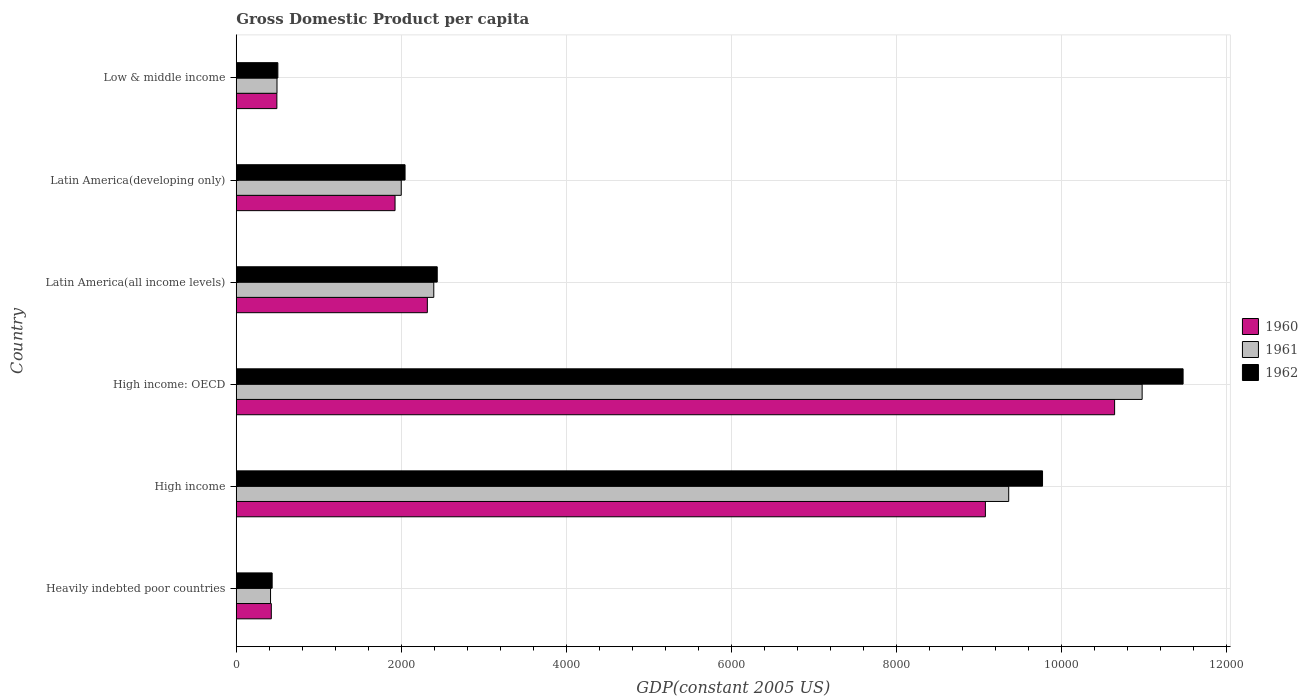How many different coloured bars are there?
Offer a terse response. 3. Are the number of bars per tick equal to the number of legend labels?
Ensure brevity in your answer.  Yes. What is the label of the 5th group of bars from the top?
Your answer should be very brief. High income. In how many cases, is the number of bars for a given country not equal to the number of legend labels?
Keep it short and to the point. 0. What is the GDP per capita in 1962 in High income?
Your response must be concise. 9773.42. Across all countries, what is the maximum GDP per capita in 1962?
Make the answer very short. 1.15e+04. Across all countries, what is the minimum GDP per capita in 1960?
Your response must be concise. 424.89. In which country was the GDP per capita in 1960 maximum?
Offer a terse response. High income: OECD. In which country was the GDP per capita in 1960 minimum?
Provide a short and direct response. Heavily indebted poor countries. What is the total GDP per capita in 1961 in the graph?
Offer a very short reply. 2.56e+04. What is the difference between the GDP per capita in 1962 in High income and that in Latin America(developing only)?
Make the answer very short. 7727.21. What is the difference between the GDP per capita in 1961 in Latin America(all income levels) and the GDP per capita in 1962 in Latin America(developing only)?
Offer a very short reply. 348.12. What is the average GDP per capita in 1962 per country?
Offer a terse response. 4445.4. What is the difference between the GDP per capita in 1960 and GDP per capita in 1962 in Low & middle income?
Your answer should be compact. -11.86. In how many countries, is the GDP per capita in 1962 greater than 3200 US$?
Your answer should be compact. 2. What is the ratio of the GDP per capita in 1962 in Heavily indebted poor countries to that in High income?
Your answer should be compact. 0.04. What is the difference between the highest and the second highest GDP per capita in 1960?
Ensure brevity in your answer.  1566.31. What is the difference between the highest and the lowest GDP per capita in 1961?
Your response must be concise. 1.06e+04. In how many countries, is the GDP per capita in 1960 greater than the average GDP per capita in 1960 taken over all countries?
Give a very brief answer. 2. Are all the bars in the graph horizontal?
Provide a succinct answer. Yes. Does the graph contain any zero values?
Offer a terse response. No. Does the graph contain grids?
Offer a very short reply. Yes. What is the title of the graph?
Keep it short and to the point. Gross Domestic Product per capita. Does "1960" appear as one of the legend labels in the graph?
Make the answer very short. Yes. What is the label or title of the X-axis?
Make the answer very short. GDP(constant 2005 US). What is the label or title of the Y-axis?
Provide a succinct answer. Country. What is the GDP(constant 2005 US) of 1960 in Heavily indebted poor countries?
Provide a short and direct response. 424.89. What is the GDP(constant 2005 US) of 1961 in Heavily indebted poor countries?
Offer a terse response. 415.63. What is the GDP(constant 2005 US) in 1962 in Heavily indebted poor countries?
Provide a short and direct response. 435.15. What is the GDP(constant 2005 US) in 1960 in High income?
Offer a terse response. 9080.74. What is the GDP(constant 2005 US) in 1961 in High income?
Provide a succinct answer. 9363.39. What is the GDP(constant 2005 US) of 1962 in High income?
Offer a very short reply. 9773.42. What is the GDP(constant 2005 US) in 1960 in High income: OECD?
Your answer should be very brief. 1.06e+04. What is the GDP(constant 2005 US) in 1961 in High income: OECD?
Keep it short and to the point. 1.10e+04. What is the GDP(constant 2005 US) of 1962 in High income: OECD?
Keep it short and to the point. 1.15e+04. What is the GDP(constant 2005 US) of 1960 in Latin America(all income levels)?
Your answer should be compact. 2316.36. What is the GDP(constant 2005 US) in 1961 in Latin America(all income levels)?
Offer a terse response. 2394.33. What is the GDP(constant 2005 US) of 1962 in Latin America(all income levels)?
Keep it short and to the point. 2436.18. What is the GDP(constant 2005 US) of 1960 in Latin America(developing only)?
Offer a very short reply. 1924.85. What is the GDP(constant 2005 US) of 1961 in Latin America(developing only)?
Give a very brief answer. 2000.07. What is the GDP(constant 2005 US) of 1962 in Latin America(developing only)?
Provide a succinct answer. 2046.21. What is the GDP(constant 2005 US) of 1960 in Low & middle income?
Offer a very short reply. 492.38. What is the GDP(constant 2005 US) of 1961 in Low & middle income?
Provide a succinct answer. 493.86. What is the GDP(constant 2005 US) in 1962 in Low & middle income?
Give a very brief answer. 504.25. Across all countries, what is the maximum GDP(constant 2005 US) in 1960?
Your answer should be very brief. 1.06e+04. Across all countries, what is the maximum GDP(constant 2005 US) in 1961?
Ensure brevity in your answer.  1.10e+04. Across all countries, what is the maximum GDP(constant 2005 US) in 1962?
Provide a short and direct response. 1.15e+04. Across all countries, what is the minimum GDP(constant 2005 US) of 1960?
Your answer should be compact. 424.89. Across all countries, what is the minimum GDP(constant 2005 US) of 1961?
Provide a short and direct response. 415.63. Across all countries, what is the minimum GDP(constant 2005 US) in 1962?
Keep it short and to the point. 435.15. What is the total GDP(constant 2005 US) in 1960 in the graph?
Ensure brevity in your answer.  2.49e+04. What is the total GDP(constant 2005 US) in 1961 in the graph?
Give a very brief answer. 2.56e+04. What is the total GDP(constant 2005 US) of 1962 in the graph?
Offer a very short reply. 2.67e+04. What is the difference between the GDP(constant 2005 US) of 1960 in Heavily indebted poor countries and that in High income?
Your response must be concise. -8655.85. What is the difference between the GDP(constant 2005 US) in 1961 in Heavily indebted poor countries and that in High income?
Give a very brief answer. -8947.77. What is the difference between the GDP(constant 2005 US) of 1962 in Heavily indebted poor countries and that in High income?
Offer a very short reply. -9338.26. What is the difference between the GDP(constant 2005 US) in 1960 in Heavily indebted poor countries and that in High income: OECD?
Ensure brevity in your answer.  -1.02e+04. What is the difference between the GDP(constant 2005 US) of 1961 in Heavily indebted poor countries and that in High income: OECD?
Provide a short and direct response. -1.06e+04. What is the difference between the GDP(constant 2005 US) of 1962 in Heavily indebted poor countries and that in High income: OECD?
Provide a succinct answer. -1.10e+04. What is the difference between the GDP(constant 2005 US) in 1960 in Heavily indebted poor countries and that in Latin America(all income levels)?
Provide a short and direct response. -1891.46. What is the difference between the GDP(constant 2005 US) in 1961 in Heavily indebted poor countries and that in Latin America(all income levels)?
Ensure brevity in your answer.  -1978.7. What is the difference between the GDP(constant 2005 US) in 1962 in Heavily indebted poor countries and that in Latin America(all income levels)?
Keep it short and to the point. -2001.03. What is the difference between the GDP(constant 2005 US) of 1960 in Heavily indebted poor countries and that in Latin America(developing only)?
Offer a terse response. -1499.95. What is the difference between the GDP(constant 2005 US) in 1961 in Heavily indebted poor countries and that in Latin America(developing only)?
Give a very brief answer. -1584.44. What is the difference between the GDP(constant 2005 US) in 1962 in Heavily indebted poor countries and that in Latin America(developing only)?
Your response must be concise. -1611.06. What is the difference between the GDP(constant 2005 US) of 1960 in Heavily indebted poor countries and that in Low & middle income?
Your answer should be very brief. -67.49. What is the difference between the GDP(constant 2005 US) of 1961 in Heavily indebted poor countries and that in Low & middle income?
Provide a succinct answer. -78.23. What is the difference between the GDP(constant 2005 US) in 1962 in Heavily indebted poor countries and that in Low & middle income?
Keep it short and to the point. -69.1. What is the difference between the GDP(constant 2005 US) of 1960 in High income and that in High income: OECD?
Make the answer very short. -1566.31. What is the difference between the GDP(constant 2005 US) of 1961 in High income and that in High income: OECD?
Provide a short and direct response. -1617.52. What is the difference between the GDP(constant 2005 US) of 1962 in High income and that in High income: OECD?
Ensure brevity in your answer.  -1703.76. What is the difference between the GDP(constant 2005 US) of 1960 in High income and that in Latin America(all income levels)?
Keep it short and to the point. 6764.39. What is the difference between the GDP(constant 2005 US) of 1961 in High income and that in Latin America(all income levels)?
Keep it short and to the point. 6969.06. What is the difference between the GDP(constant 2005 US) of 1962 in High income and that in Latin America(all income levels)?
Ensure brevity in your answer.  7337.24. What is the difference between the GDP(constant 2005 US) in 1960 in High income and that in Latin America(developing only)?
Provide a succinct answer. 7155.9. What is the difference between the GDP(constant 2005 US) in 1961 in High income and that in Latin America(developing only)?
Offer a terse response. 7363.32. What is the difference between the GDP(constant 2005 US) of 1962 in High income and that in Latin America(developing only)?
Offer a terse response. 7727.21. What is the difference between the GDP(constant 2005 US) of 1960 in High income and that in Low & middle income?
Give a very brief answer. 8588.36. What is the difference between the GDP(constant 2005 US) of 1961 in High income and that in Low & middle income?
Your answer should be compact. 8869.54. What is the difference between the GDP(constant 2005 US) of 1962 in High income and that in Low & middle income?
Provide a short and direct response. 9269.17. What is the difference between the GDP(constant 2005 US) of 1960 in High income: OECD and that in Latin America(all income levels)?
Keep it short and to the point. 8330.7. What is the difference between the GDP(constant 2005 US) of 1961 in High income: OECD and that in Latin America(all income levels)?
Provide a succinct answer. 8586.58. What is the difference between the GDP(constant 2005 US) in 1962 in High income: OECD and that in Latin America(all income levels)?
Your answer should be compact. 9041. What is the difference between the GDP(constant 2005 US) of 1960 in High income: OECD and that in Latin America(developing only)?
Give a very brief answer. 8722.21. What is the difference between the GDP(constant 2005 US) of 1961 in High income: OECD and that in Latin America(developing only)?
Provide a short and direct response. 8980.84. What is the difference between the GDP(constant 2005 US) in 1962 in High income: OECD and that in Latin America(developing only)?
Provide a short and direct response. 9430.97. What is the difference between the GDP(constant 2005 US) of 1960 in High income: OECD and that in Low & middle income?
Make the answer very short. 1.02e+04. What is the difference between the GDP(constant 2005 US) in 1961 in High income: OECD and that in Low & middle income?
Ensure brevity in your answer.  1.05e+04. What is the difference between the GDP(constant 2005 US) in 1962 in High income: OECD and that in Low & middle income?
Provide a succinct answer. 1.10e+04. What is the difference between the GDP(constant 2005 US) of 1960 in Latin America(all income levels) and that in Latin America(developing only)?
Provide a succinct answer. 391.51. What is the difference between the GDP(constant 2005 US) of 1961 in Latin America(all income levels) and that in Latin America(developing only)?
Offer a very short reply. 394.26. What is the difference between the GDP(constant 2005 US) in 1962 in Latin America(all income levels) and that in Latin America(developing only)?
Keep it short and to the point. 389.97. What is the difference between the GDP(constant 2005 US) in 1960 in Latin America(all income levels) and that in Low & middle income?
Provide a succinct answer. 1823.97. What is the difference between the GDP(constant 2005 US) in 1961 in Latin America(all income levels) and that in Low & middle income?
Make the answer very short. 1900.47. What is the difference between the GDP(constant 2005 US) of 1962 in Latin America(all income levels) and that in Low & middle income?
Provide a succinct answer. 1931.93. What is the difference between the GDP(constant 2005 US) in 1960 in Latin America(developing only) and that in Low & middle income?
Offer a very short reply. 1432.46. What is the difference between the GDP(constant 2005 US) of 1961 in Latin America(developing only) and that in Low & middle income?
Provide a short and direct response. 1506.21. What is the difference between the GDP(constant 2005 US) in 1962 in Latin America(developing only) and that in Low & middle income?
Keep it short and to the point. 1541.96. What is the difference between the GDP(constant 2005 US) in 1960 in Heavily indebted poor countries and the GDP(constant 2005 US) in 1961 in High income?
Offer a very short reply. -8938.5. What is the difference between the GDP(constant 2005 US) in 1960 in Heavily indebted poor countries and the GDP(constant 2005 US) in 1962 in High income?
Provide a succinct answer. -9348.52. What is the difference between the GDP(constant 2005 US) in 1961 in Heavily indebted poor countries and the GDP(constant 2005 US) in 1962 in High income?
Provide a short and direct response. -9357.79. What is the difference between the GDP(constant 2005 US) of 1960 in Heavily indebted poor countries and the GDP(constant 2005 US) of 1961 in High income: OECD?
Your answer should be very brief. -1.06e+04. What is the difference between the GDP(constant 2005 US) in 1960 in Heavily indebted poor countries and the GDP(constant 2005 US) in 1962 in High income: OECD?
Provide a short and direct response. -1.11e+04. What is the difference between the GDP(constant 2005 US) of 1961 in Heavily indebted poor countries and the GDP(constant 2005 US) of 1962 in High income: OECD?
Offer a terse response. -1.11e+04. What is the difference between the GDP(constant 2005 US) of 1960 in Heavily indebted poor countries and the GDP(constant 2005 US) of 1961 in Latin America(all income levels)?
Provide a succinct answer. -1969.44. What is the difference between the GDP(constant 2005 US) in 1960 in Heavily indebted poor countries and the GDP(constant 2005 US) in 1962 in Latin America(all income levels)?
Your response must be concise. -2011.29. What is the difference between the GDP(constant 2005 US) of 1961 in Heavily indebted poor countries and the GDP(constant 2005 US) of 1962 in Latin America(all income levels)?
Your response must be concise. -2020.55. What is the difference between the GDP(constant 2005 US) of 1960 in Heavily indebted poor countries and the GDP(constant 2005 US) of 1961 in Latin America(developing only)?
Ensure brevity in your answer.  -1575.17. What is the difference between the GDP(constant 2005 US) in 1960 in Heavily indebted poor countries and the GDP(constant 2005 US) in 1962 in Latin America(developing only)?
Your response must be concise. -1621.32. What is the difference between the GDP(constant 2005 US) of 1961 in Heavily indebted poor countries and the GDP(constant 2005 US) of 1962 in Latin America(developing only)?
Ensure brevity in your answer.  -1630.59. What is the difference between the GDP(constant 2005 US) in 1960 in Heavily indebted poor countries and the GDP(constant 2005 US) in 1961 in Low & middle income?
Offer a terse response. -68.96. What is the difference between the GDP(constant 2005 US) in 1960 in Heavily indebted poor countries and the GDP(constant 2005 US) in 1962 in Low & middle income?
Your response must be concise. -79.36. What is the difference between the GDP(constant 2005 US) of 1961 in Heavily indebted poor countries and the GDP(constant 2005 US) of 1962 in Low & middle income?
Offer a terse response. -88.62. What is the difference between the GDP(constant 2005 US) in 1960 in High income and the GDP(constant 2005 US) in 1961 in High income: OECD?
Offer a very short reply. -1900.16. What is the difference between the GDP(constant 2005 US) of 1960 in High income and the GDP(constant 2005 US) of 1962 in High income: OECD?
Your answer should be very brief. -2396.44. What is the difference between the GDP(constant 2005 US) in 1961 in High income and the GDP(constant 2005 US) in 1962 in High income: OECD?
Offer a terse response. -2113.79. What is the difference between the GDP(constant 2005 US) in 1960 in High income and the GDP(constant 2005 US) in 1961 in Latin America(all income levels)?
Provide a short and direct response. 6686.42. What is the difference between the GDP(constant 2005 US) in 1960 in High income and the GDP(constant 2005 US) in 1962 in Latin America(all income levels)?
Keep it short and to the point. 6644.56. What is the difference between the GDP(constant 2005 US) of 1961 in High income and the GDP(constant 2005 US) of 1962 in Latin America(all income levels)?
Your answer should be very brief. 6927.21. What is the difference between the GDP(constant 2005 US) in 1960 in High income and the GDP(constant 2005 US) in 1961 in Latin America(developing only)?
Provide a succinct answer. 7080.68. What is the difference between the GDP(constant 2005 US) of 1960 in High income and the GDP(constant 2005 US) of 1962 in Latin America(developing only)?
Offer a very short reply. 7034.53. What is the difference between the GDP(constant 2005 US) of 1961 in High income and the GDP(constant 2005 US) of 1962 in Latin America(developing only)?
Provide a succinct answer. 7317.18. What is the difference between the GDP(constant 2005 US) of 1960 in High income and the GDP(constant 2005 US) of 1961 in Low & middle income?
Your answer should be compact. 8586.89. What is the difference between the GDP(constant 2005 US) of 1960 in High income and the GDP(constant 2005 US) of 1962 in Low & middle income?
Make the answer very short. 8576.49. What is the difference between the GDP(constant 2005 US) of 1961 in High income and the GDP(constant 2005 US) of 1962 in Low & middle income?
Ensure brevity in your answer.  8859.14. What is the difference between the GDP(constant 2005 US) of 1960 in High income: OECD and the GDP(constant 2005 US) of 1961 in Latin America(all income levels)?
Your response must be concise. 8252.73. What is the difference between the GDP(constant 2005 US) of 1960 in High income: OECD and the GDP(constant 2005 US) of 1962 in Latin America(all income levels)?
Provide a short and direct response. 8210.87. What is the difference between the GDP(constant 2005 US) in 1961 in High income: OECD and the GDP(constant 2005 US) in 1962 in Latin America(all income levels)?
Ensure brevity in your answer.  8544.73. What is the difference between the GDP(constant 2005 US) of 1960 in High income: OECD and the GDP(constant 2005 US) of 1961 in Latin America(developing only)?
Provide a succinct answer. 8646.99. What is the difference between the GDP(constant 2005 US) in 1960 in High income: OECD and the GDP(constant 2005 US) in 1962 in Latin America(developing only)?
Your response must be concise. 8600.84. What is the difference between the GDP(constant 2005 US) of 1961 in High income: OECD and the GDP(constant 2005 US) of 1962 in Latin America(developing only)?
Your answer should be very brief. 8934.7. What is the difference between the GDP(constant 2005 US) of 1960 in High income: OECD and the GDP(constant 2005 US) of 1961 in Low & middle income?
Make the answer very short. 1.02e+04. What is the difference between the GDP(constant 2005 US) of 1960 in High income: OECD and the GDP(constant 2005 US) of 1962 in Low & middle income?
Your response must be concise. 1.01e+04. What is the difference between the GDP(constant 2005 US) in 1961 in High income: OECD and the GDP(constant 2005 US) in 1962 in Low & middle income?
Provide a short and direct response. 1.05e+04. What is the difference between the GDP(constant 2005 US) in 1960 in Latin America(all income levels) and the GDP(constant 2005 US) in 1961 in Latin America(developing only)?
Provide a succinct answer. 316.29. What is the difference between the GDP(constant 2005 US) of 1960 in Latin America(all income levels) and the GDP(constant 2005 US) of 1962 in Latin America(developing only)?
Make the answer very short. 270.14. What is the difference between the GDP(constant 2005 US) in 1961 in Latin America(all income levels) and the GDP(constant 2005 US) in 1962 in Latin America(developing only)?
Keep it short and to the point. 348.12. What is the difference between the GDP(constant 2005 US) of 1960 in Latin America(all income levels) and the GDP(constant 2005 US) of 1961 in Low & middle income?
Provide a short and direct response. 1822.5. What is the difference between the GDP(constant 2005 US) in 1960 in Latin America(all income levels) and the GDP(constant 2005 US) in 1962 in Low & middle income?
Provide a short and direct response. 1812.11. What is the difference between the GDP(constant 2005 US) in 1961 in Latin America(all income levels) and the GDP(constant 2005 US) in 1962 in Low & middle income?
Keep it short and to the point. 1890.08. What is the difference between the GDP(constant 2005 US) of 1960 in Latin America(developing only) and the GDP(constant 2005 US) of 1961 in Low & middle income?
Offer a terse response. 1430.99. What is the difference between the GDP(constant 2005 US) in 1960 in Latin America(developing only) and the GDP(constant 2005 US) in 1962 in Low & middle income?
Ensure brevity in your answer.  1420.6. What is the difference between the GDP(constant 2005 US) of 1961 in Latin America(developing only) and the GDP(constant 2005 US) of 1962 in Low & middle income?
Give a very brief answer. 1495.82. What is the average GDP(constant 2005 US) of 1960 per country?
Your answer should be very brief. 4147.71. What is the average GDP(constant 2005 US) of 1961 per country?
Your answer should be compact. 4274.7. What is the average GDP(constant 2005 US) in 1962 per country?
Offer a terse response. 4445.4. What is the difference between the GDP(constant 2005 US) of 1960 and GDP(constant 2005 US) of 1961 in Heavily indebted poor countries?
Make the answer very short. 9.27. What is the difference between the GDP(constant 2005 US) of 1960 and GDP(constant 2005 US) of 1962 in Heavily indebted poor countries?
Make the answer very short. -10.26. What is the difference between the GDP(constant 2005 US) of 1961 and GDP(constant 2005 US) of 1962 in Heavily indebted poor countries?
Keep it short and to the point. -19.53. What is the difference between the GDP(constant 2005 US) of 1960 and GDP(constant 2005 US) of 1961 in High income?
Keep it short and to the point. -282.65. What is the difference between the GDP(constant 2005 US) of 1960 and GDP(constant 2005 US) of 1962 in High income?
Give a very brief answer. -692.67. What is the difference between the GDP(constant 2005 US) of 1961 and GDP(constant 2005 US) of 1962 in High income?
Offer a terse response. -410.03. What is the difference between the GDP(constant 2005 US) of 1960 and GDP(constant 2005 US) of 1961 in High income: OECD?
Make the answer very short. -333.85. What is the difference between the GDP(constant 2005 US) in 1960 and GDP(constant 2005 US) in 1962 in High income: OECD?
Your response must be concise. -830.12. What is the difference between the GDP(constant 2005 US) of 1961 and GDP(constant 2005 US) of 1962 in High income: OECD?
Offer a terse response. -496.27. What is the difference between the GDP(constant 2005 US) in 1960 and GDP(constant 2005 US) in 1961 in Latin America(all income levels)?
Provide a short and direct response. -77.97. What is the difference between the GDP(constant 2005 US) of 1960 and GDP(constant 2005 US) of 1962 in Latin America(all income levels)?
Provide a short and direct response. -119.82. What is the difference between the GDP(constant 2005 US) of 1961 and GDP(constant 2005 US) of 1962 in Latin America(all income levels)?
Provide a short and direct response. -41.85. What is the difference between the GDP(constant 2005 US) in 1960 and GDP(constant 2005 US) in 1961 in Latin America(developing only)?
Offer a terse response. -75.22. What is the difference between the GDP(constant 2005 US) of 1960 and GDP(constant 2005 US) of 1962 in Latin America(developing only)?
Your response must be concise. -121.36. What is the difference between the GDP(constant 2005 US) of 1961 and GDP(constant 2005 US) of 1962 in Latin America(developing only)?
Your answer should be very brief. -46.14. What is the difference between the GDP(constant 2005 US) in 1960 and GDP(constant 2005 US) in 1961 in Low & middle income?
Offer a terse response. -1.47. What is the difference between the GDP(constant 2005 US) in 1960 and GDP(constant 2005 US) in 1962 in Low & middle income?
Provide a short and direct response. -11.86. What is the difference between the GDP(constant 2005 US) of 1961 and GDP(constant 2005 US) of 1962 in Low & middle income?
Offer a terse response. -10.39. What is the ratio of the GDP(constant 2005 US) of 1960 in Heavily indebted poor countries to that in High income?
Provide a succinct answer. 0.05. What is the ratio of the GDP(constant 2005 US) of 1961 in Heavily indebted poor countries to that in High income?
Make the answer very short. 0.04. What is the ratio of the GDP(constant 2005 US) in 1962 in Heavily indebted poor countries to that in High income?
Your response must be concise. 0.04. What is the ratio of the GDP(constant 2005 US) in 1960 in Heavily indebted poor countries to that in High income: OECD?
Give a very brief answer. 0.04. What is the ratio of the GDP(constant 2005 US) of 1961 in Heavily indebted poor countries to that in High income: OECD?
Give a very brief answer. 0.04. What is the ratio of the GDP(constant 2005 US) in 1962 in Heavily indebted poor countries to that in High income: OECD?
Your response must be concise. 0.04. What is the ratio of the GDP(constant 2005 US) in 1960 in Heavily indebted poor countries to that in Latin America(all income levels)?
Provide a short and direct response. 0.18. What is the ratio of the GDP(constant 2005 US) in 1961 in Heavily indebted poor countries to that in Latin America(all income levels)?
Ensure brevity in your answer.  0.17. What is the ratio of the GDP(constant 2005 US) of 1962 in Heavily indebted poor countries to that in Latin America(all income levels)?
Give a very brief answer. 0.18. What is the ratio of the GDP(constant 2005 US) of 1960 in Heavily indebted poor countries to that in Latin America(developing only)?
Your answer should be very brief. 0.22. What is the ratio of the GDP(constant 2005 US) in 1961 in Heavily indebted poor countries to that in Latin America(developing only)?
Provide a short and direct response. 0.21. What is the ratio of the GDP(constant 2005 US) in 1962 in Heavily indebted poor countries to that in Latin America(developing only)?
Offer a very short reply. 0.21. What is the ratio of the GDP(constant 2005 US) in 1960 in Heavily indebted poor countries to that in Low & middle income?
Your answer should be compact. 0.86. What is the ratio of the GDP(constant 2005 US) in 1961 in Heavily indebted poor countries to that in Low & middle income?
Provide a succinct answer. 0.84. What is the ratio of the GDP(constant 2005 US) in 1962 in Heavily indebted poor countries to that in Low & middle income?
Give a very brief answer. 0.86. What is the ratio of the GDP(constant 2005 US) of 1960 in High income to that in High income: OECD?
Make the answer very short. 0.85. What is the ratio of the GDP(constant 2005 US) of 1961 in High income to that in High income: OECD?
Provide a short and direct response. 0.85. What is the ratio of the GDP(constant 2005 US) of 1962 in High income to that in High income: OECD?
Make the answer very short. 0.85. What is the ratio of the GDP(constant 2005 US) of 1960 in High income to that in Latin America(all income levels)?
Provide a short and direct response. 3.92. What is the ratio of the GDP(constant 2005 US) of 1961 in High income to that in Latin America(all income levels)?
Your answer should be compact. 3.91. What is the ratio of the GDP(constant 2005 US) of 1962 in High income to that in Latin America(all income levels)?
Provide a short and direct response. 4.01. What is the ratio of the GDP(constant 2005 US) in 1960 in High income to that in Latin America(developing only)?
Provide a short and direct response. 4.72. What is the ratio of the GDP(constant 2005 US) of 1961 in High income to that in Latin America(developing only)?
Offer a very short reply. 4.68. What is the ratio of the GDP(constant 2005 US) of 1962 in High income to that in Latin America(developing only)?
Keep it short and to the point. 4.78. What is the ratio of the GDP(constant 2005 US) of 1960 in High income to that in Low & middle income?
Offer a terse response. 18.44. What is the ratio of the GDP(constant 2005 US) of 1961 in High income to that in Low & middle income?
Your answer should be very brief. 18.96. What is the ratio of the GDP(constant 2005 US) in 1962 in High income to that in Low & middle income?
Give a very brief answer. 19.38. What is the ratio of the GDP(constant 2005 US) of 1960 in High income: OECD to that in Latin America(all income levels)?
Your answer should be compact. 4.6. What is the ratio of the GDP(constant 2005 US) in 1961 in High income: OECD to that in Latin America(all income levels)?
Your answer should be compact. 4.59. What is the ratio of the GDP(constant 2005 US) of 1962 in High income: OECD to that in Latin America(all income levels)?
Your answer should be very brief. 4.71. What is the ratio of the GDP(constant 2005 US) of 1960 in High income: OECD to that in Latin America(developing only)?
Keep it short and to the point. 5.53. What is the ratio of the GDP(constant 2005 US) in 1961 in High income: OECD to that in Latin America(developing only)?
Provide a short and direct response. 5.49. What is the ratio of the GDP(constant 2005 US) in 1962 in High income: OECD to that in Latin America(developing only)?
Provide a short and direct response. 5.61. What is the ratio of the GDP(constant 2005 US) of 1960 in High income: OECD to that in Low & middle income?
Your answer should be very brief. 21.62. What is the ratio of the GDP(constant 2005 US) in 1961 in High income: OECD to that in Low & middle income?
Ensure brevity in your answer.  22.24. What is the ratio of the GDP(constant 2005 US) in 1962 in High income: OECD to that in Low & middle income?
Your answer should be very brief. 22.76. What is the ratio of the GDP(constant 2005 US) of 1960 in Latin America(all income levels) to that in Latin America(developing only)?
Offer a terse response. 1.2. What is the ratio of the GDP(constant 2005 US) in 1961 in Latin America(all income levels) to that in Latin America(developing only)?
Offer a very short reply. 1.2. What is the ratio of the GDP(constant 2005 US) of 1962 in Latin America(all income levels) to that in Latin America(developing only)?
Provide a succinct answer. 1.19. What is the ratio of the GDP(constant 2005 US) in 1960 in Latin America(all income levels) to that in Low & middle income?
Make the answer very short. 4.7. What is the ratio of the GDP(constant 2005 US) in 1961 in Latin America(all income levels) to that in Low & middle income?
Make the answer very short. 4.85. What is the ratio of the GDP(constant 2005 US) in 1962 in Latin America(all income levels) to that in Low & middle income?
Your answer should be very brief. 4.83. What is the ratio of the GDP(constant 2005 US) of 1960 in Latin America(developing only) to that in Low & middle income?
Offer a terse response. 3.91. What is the ratio of the GDP(constant 2005 US) of 1961 in Latin America(developing only) to that in Low & middle income?
Offer a terse response. 4.05. What is the ratio of the GDP(constant 2005 US) in 1962 in Latin America(developing only) to that in Low & middle income?
Ensure brevity in your answer.  4.06. What is the difference between the highest and the second highest GDP(constant 2005 US) of 1960?
Offer a terse response. 1566.31. What is the difference between the highest and the second highest GDP(constant 2005 US) of 1961?
Offer a terse response. 1617.52. What is the difference between the highest and the second highest GDP(constant 2005 US) in 1962?
Your answer should be very brief. 1703.76. What is the difference between the highest and the lowest GDP(constant 2005 US) of 1960?
Make the answer very short. 1.02e+04. What is the difference between the highest and the lowest GDP(constant 2005 US) of 1961?
Your response must be concise. 1.06e+04. What is the difference between the highest and the lowest GDP(constant 2005 US) of 1962?
Offer a very short reply. 1.10e+04. 